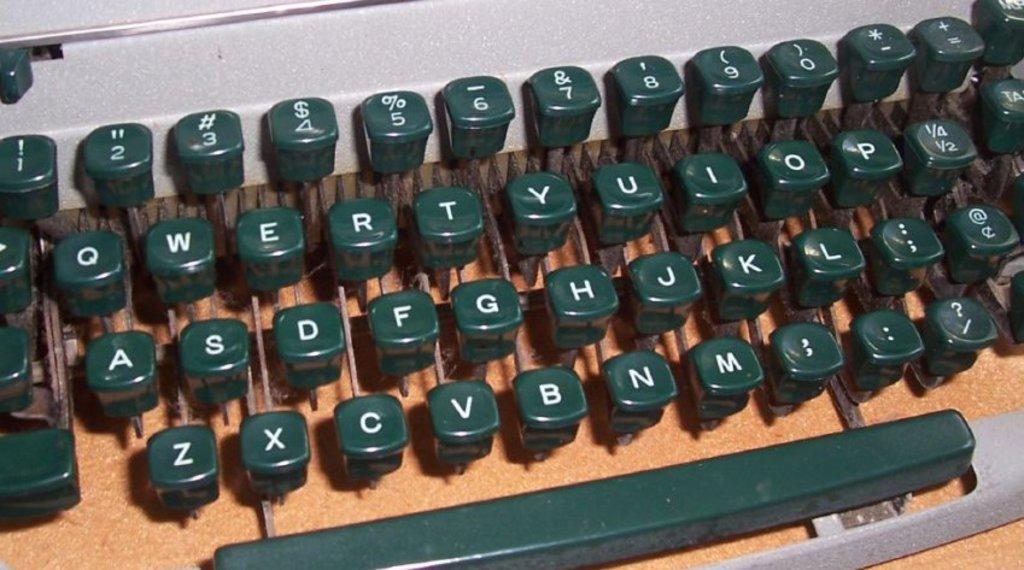What is one of the numbers on this typewriter?
Your answer should be compact. 6. What is the first letter in the bottom row of keys?
Ensure brevity in your answer.  Z. 